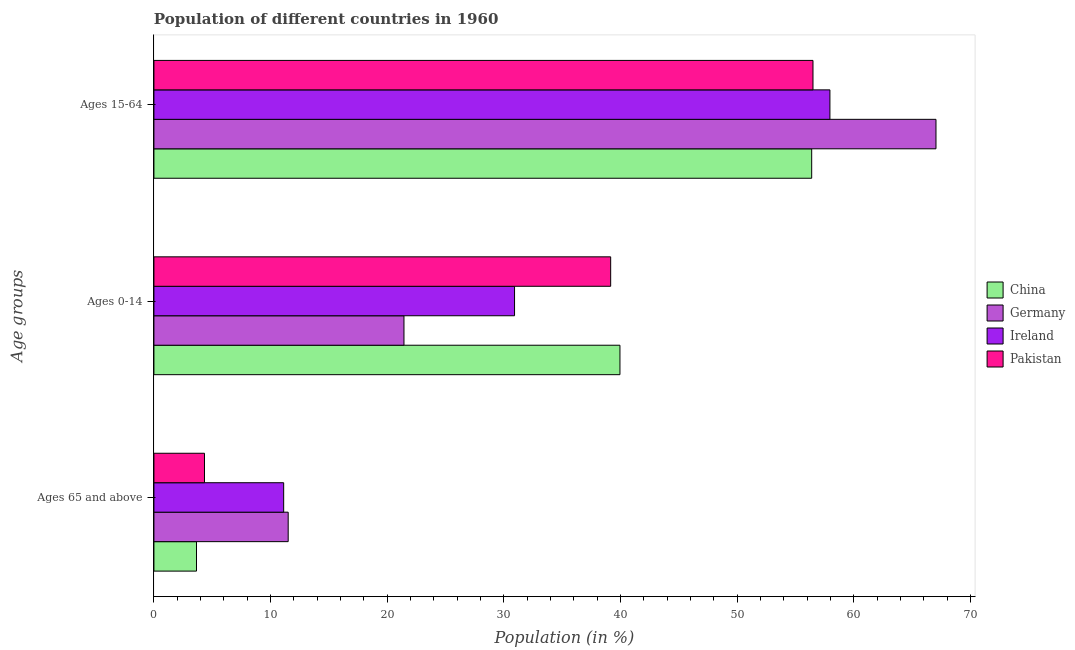How many different coloured bars are there?
Provide a succinct answer. 4. Are the number of bars per tick equal to the number of legend labels?
Ensure brevity in your answer.  Yes. What is the label of the 2nd group of bars from the top?
Ensure brevity in your answer.  Ages 0-14. What is the percentage of population within the age-group of 65 and above in Pakistan?
Provide a short and direct response. 4.33. Across all countries, what is the maximum percentage of population within the age-group 15-64?
Make the answer very short. 67.05. Across all countries, what is the minimum percentage of population within the age-group 0-14?
Offer a terse response. 21.44. In which country was the percentage of population within the age-group 0-14 maximum?
Your answer should be compact. China. In which country was the percentage of population within the age-group of 65 and above minimum?
Ensure brevity in your answer.  China. What is the total percentage of population within the age-group 0-14 in the graph?
Provide a short and direct response. 131.47. What is the difference between the percentage of population within the age-group 0-14 in Pakistan and that in China?
Give a very brief answer. -0.8. What is the difference between the percentage of population within the age-group of 65 and above in Ireland and the percentage of population within the age-group 0-14 in Pakistan?
Your answer should be very brief. -28.04. What is the average percentage of population within the age-group 15-64 per country?
Provide a short and direct response. 59.48. What is the difference between the percentage of population within the age-group 0-14 and percentage of population within the age-group of 65 and above in Germany?
Ensure brevity in your answer.  9.93. What is the ratio of the percentage of population within the age-group of 65 and above in Pakistan to that in China?
Give a very brief answer. 1.19. What is the difference between the highest and the second highest percentage of population within the age-group 0-14?
Ensure brevity in your answer.  0.8. What is the difference between the highest and the lowest percentage of population within the age-group 0-14?
Provide a succinct answer. 18.52. What does the 4th bar from the top in Ages 65 and above represents?
Your answer should be compact. China. What does the 4th bar from the bottom in Ages 65 and above represents?
Your response must be concise. Pakistan. Are all the bars in the graph horizontal?
Your response must be concise. Yes. How many countries are there in the graph?
Ensure brevity in your answer.  4. What is the difference between two consecutive major ticks on the X-axis?
Ensure brevity in your answer.  10. Are the values on the major ticks of X-axis written in scientific E-notation?
Provide a succinct answer. No. Does the graph contain any zero values?
Your answer should be very brief. No. Where does the legend appear in the graph?
Give a very brief answer. Center right. How are the legend labels stacked?
Provide a succinct answer. Vertical. What is the title of the graph?
Offer a very short reply. Population of different countries in 1960. Does "Chile" appear as one of the legend labels in the graph?
Give a very brief answer. No. What is the label or title of the X-axis?
Offer a terse response. Population (in %). What is the label or title of the Y-axis?
Keep it short and to the point. Age groups. What is the Population (in %) of China in Ages 65 and above?
Provide a succinct answer. 3.65. What is the Population (in %) of Germany in Ages 65 and above?
Offer a very short reply. 11.51. What is the Population (in %) of Ireland in Ages 65 and above?
Give a very brief answer. 11.12. What is the Population (in %) of Pakistan in Ages 65 and above?
Keep it short and to the point. 4.33. What is the Population (in %) in China in Ages 0-14?
Offer a very short reply. 39.96. What is the Population (in %) in Germany in Ages 0-14?
Offer a very short reply. 21.44. What is the Population (in %) in Ireland in Ages 0-14?
Your response must be concise. 30.92. What is the Population (in %) of Pakistan in Ages 0-14?
Your answer should be very brief. 39.16. What is the Population (in %) in China in Ages 15-64?
Your response must be concise. 56.39. What is the Population (in %) of Germany in Ages 15-64?
Give a very brief answer. 67.05. What is the Population (in %) of Ireland in Ages 15-64?
Your response must be concise. 57.96. What is the Population (in %) of Pakistan in Ages 15-64?
Your answer should be compact. 56.51. Across all Age groups, what is the maximum Population (in %) of China?
Ensure brevity in your answer.  56.39. Across all Age groups, what is the maximum Population (in %) of Germany?
Your answer should be very brief. 67.05. Across all Age groups, what is the maximum Population (in %) of Ireland?
Your answer should be compact. 57.96. Across all Age groups, what is the maximum Population (in %) in Pakistan?
Your answer should be very brief. 56.51. Across all Age groups, what is the minimum Population (in %) of China?
Provide a short and direct response. 3.65. Across all Age groups, what is the minimum Population (in %) of Germany?
Your answer should be very brief. 11.51. Across all Age groups, what is the minimum Population (in %) of Ireland?
Offer a very short reply. 11.12. Across all Age groups, what is the minimum Population (in %) of Pakistan?
Offer a terse response. 4.33. What is the total Population (in %) in China in the graph?
Keep it short and to the point. 100. What is the total Population (in %) in Pakistan in the graph?
Offer a very short reply. 100. What is the difference between the Population (in %) in China in Ages 65 and above and that in Ages 0-14?
Your response must be concise. -36.31. What is the difference between the Population (in %) of Germany in Ages 65 and above and that in Ages 0-14?
Provide a short and direct response. -9.93. What is the difference between the Population (in %) in Ireland in Ages 65 and above and that in Ages 0-14?
Your response must be concise. -19.79. What is the difference between the Population (in %) of Pakistan in Ages 65 and above and that in Ages 0-14?
Offer a terse response. -34.83. What is the difference between the Population (in %) of China in Ages 65 and above and that in Ages 15-64?
Ensure brevity in your answer.  -52.74. What is the difference between the Population (in %) in Germany in Ages 65 and above and that in Ages 15-64?
Keep it short and to the point. -55.54. What is the difference between the Population (in %) of Ireland in Ages 65 and above and that in Ages 15-64?
Your response must be concise. -46.83. What is the difference between the Population (in %) in Pakistan in Ages 65 and above and that in Ages 15-64?
Offer a very short reply. -52.17. What is the difference between the Population (in %) in China in Ages 0-14 and that in Ages 15-64?
Your answer should be compact. -16.44. What is the difference between the Population (in %) in Germany in Ages 0-14 and that in Ages 15-64?
Offer a terse response. -45.61. What is the difference between the Population (in %) of Ireland in Ages 0-14 and that in Ages 15-64?
Your response must be concise. -27.04. What is the difference between the Population (in %) in Pakistan in Ages 0-14 and that in Ages 15-64?
Your answer should be very brief. -17.35. What is the difference between the Population (in %) in China in Ages 65 and above and the Population (in %) in Germany in Ages 0-14?
Offer a very short reply. -17.79. What is the difference between the Population (in %) of China in Ages 65 and above and the Population (in %) of Ireland in Ages 0-14?
Your answer should be compact. -27.27. What is the difference between the Population (in %) of China in Ages 65 and above and the Population (in %) of Pakistan in Ages 0-14?
Offer a terse response. -35.51. What is the difference between the Population (in %) of Germany in Ages 65 and above and the Population (in %) of Ireland in Ages 0-14?
Your answer should be very brief. -19.41. What is the difference between the Population (in %) of Germany in Ages 65 and above and the Population (in %) of Pakistan in Ages 0-14?
Your response must be concise. -27.65. What is the difference between the Population (in %) in Ireland in Ages 65 and above and the Population (in %) in Pakistan in Ages 0-14?
Provide a succinct answer. -28.04. What is the difference between the Population (in %) in China in Ages 65 and above and the Population (in %) in Germany in Ages 15-64?
Provide a succinct answer. -63.4. What is the difference between the Population (in %) of China in Ages 65 and above and the Population (in %) of Ireland in Ages 15-64?
Your answer should be very brief. -54.31. What is the difference between the Population (in %) in China in Ages 65 and above and the Population (in %) in Pakistan in Ages 15-64?
Make the answer very short. -52.86. What is the difference between the Population (in %) of Germany in Ages 65 and above and the Population (in %) of Ireland in Ages 15-64?
Offer a very short reply. -46.45. What is the difference between the Population (in %) in Germany in Ages 65 and above and the Population (in %) in Pakistan in Ages 15-64?
Offer a very short reply. -44.99. What is the difference between the Population (in %) of Ireland in Ages 65 and above and the Population (in %) of Pakistan in Ages 15-64?
Provide a short and direct response. -45.38. What is the difference between the Population (in %) of China in Ages 0-14 and the Population (in %) of Germany in Ages 15-64?
Your answer should be very brief. -27.1. What is the difference between the Population (in %) of China in Ages 0-14 and the Population (in %) of Ireland in Ages 15-64?
Ensure brevity in your answer.  -18. What is the difference between the Population (in %) of China in Ages 0-14 and the Population (in %) of Pakistan in Ages 15-64?
Keep it short and to the point. -16.55. What is the difference between the Population (in %) of Germany in Ages 0-14 and the Population (in %) of Ireland in Ages 15-64?
Offer a terse response. -36.52. What is the difference between the Population (in %) of Germany in Ages 0-14 and the Population (in %) of Pakistan in Ages 15-64?
Ensure brevity in your answer.  -35.07. What is the difference between the Population (in %) of Ireland in Ages 0-14 and the Population (in %) of Pakistan in Ages 15-64?
Make the answer very short. -25.59. What is the average Population (in %) of China per Age groups?
Provide a succinct answer. 33.33. What is the average Population (in %) of Germany per Age groups?
Make the answer very short. 33.33. What is the average Population (in %) of Ireland per Age groups?
Make the answer very short. 33.33. What is the average Population (in %) in Pakistan per Age groups?
Provide a succinct answer. 33.33. What is the difference between the Population (in %) in China and Population (in %) in Germany in Ages 65 and above?
Your answer should be compact. -7.86. What is the difference between the Population (in %) of China and Population (in %) of Ireland in Ages 65 and above?
Your answer should be very brief. -7.47. What is the difference between the Population (in %) in China and Population (in %) in Pakistan in Ages 65 and above?
Ensure brevity in your answer.  -0.68. What is the difference between the Population (in %) of Germany and Population (in %) of Ireland in Ages 65 and above?
Make the answer very short. 0.39. What is the difference between the Population (in %) of Germany and Population (in %) of Pakistan in Ages 65 and above?
Keep it short and to the point. 7.18. What is the difference between the Population (in %) in Ireland and Population (in %) in Pakistan in Ages 65 and above?
Your response must be concise. 6.79. What is the difference between the Population (in %) in China and Population (in %) in Germany in Ages 0-14?
Offer a very short reply. 18.52. What is the difference between the Population (in %) of China and Population (in %) of Ireland in Ages 0-14?
Your answer should be very brief. 9.04. What is the difference between the Population (in %) in China and Population (in %) in Pakistan in Ages 0-14?
Ensure brevity in your answer.  0.8. What is the difference between the Population (in %) of Germany and Population (in %) of Ireland in Ages 0-14?
Provide a succinct answer. -9.48. What is the difference between the Population (in %) of Germany and Population (in %) of Pakistan in Ages 0-14?
Provide a short and direct response. -17.72. What is the difference between the Population (in %) in Ireland and Population (in %) in Pakistan in Ages 0-14?
Give a very brief answer. -8.24. What is the difference between the Population (in %) of China and Population (in %) of Germany in Ages 15-64?
Your response must be concise. -10.66. What is the difference between the Population (in %) of China and Population (in %) of Ireland in Ages 15-64?
Offer a very short reply. -1.56. What is the difference between the Population (in %) of China and Population (in %) of Pakistan in Ages 15-64?
Your answer should be compact. -0.11. What is the difference between the Population (in %) in Germany and Population (in %) in Ireland in Ages 15-64?
Provide a short and direct response. 9.09. What is the difference between the Population (in %) in Germany and Population (in %) in Pakistan in Ages 15-64?
Offer a terse response. 10.54. What is the difference between the Population (in %) of Ireland and Population (in %) of Pakistan in Ages 15-64?
Keep it short and to the point. 1.45. What is the ratio of the Population (in %) of China in Ages 65 and above to that in Ages 0-14?
Provide a succinct answer. 0.09. What is the ratio of the Population (in %) of Germany in Ages 65 and above to that in Ages 0-14?
Keep it short and to the point. 0.54. What is the ratio of the Population (in %) in Ireland in Ages 65 and above to that in Ages 0-14?
Ensure brevity in your answer.  0.36. What is the ratio of the Population (in %) of Pakistan in Ages 65 and above to that in Ages 0-14?
Your answer should be very brief. 0.11. What is the ratio of the Population (in %) of China in Ages 65 and above to that in Ages 15-64?
Your answer should be compact. 0.06. What is the ratio of the Population (in %) in Germany in Ages 65 and above to that in Ages 15-64?
Provide a succinct answer. 0.17. What is the ratio of the Population (in %) of Ireland in Ages 65 and above to that in Ages 15-64?
Your answer should be compact. 0.19. What is the ratio of the Population (in %) of Pakistan in Ages 65 and above to that in Ages 15-64?
Offer a terse response. 0.08. What is the ratio of the Population (in %) in China in Ages 0-14 to that in Ages 15-64?
Give a very brief answer. 0.71. What is the ratio of the Population (in %) of Germany in Ages 0-14 to that in Ages 15-64?
Provide a succinct answer. 0.32. What is the ratio of the Population (in %) in Ireland in Ages 0-14 to that in Ages 15-64?
Your response must be concise. 0.53. What is the ratio of the Population (in %) of Pakistan in Ages 0-14 to that in Ages 15-64?
Provide a short and direct response. 0.69. What is the difference between the highest and the second highest Population (in %) of China?
Provide a succinct answer. 16.44. What is the difference between the highest and the second highest Population (in %) of Germany?
Provide a short and direct response. 45.61. What is the difference between the highest and the second highest Population (in %) of Ireland?
Your answer should be very brief. 27.04. What is the difference between the highest and the second highest Population (in %) in Pakistan?
Keep it short and to the point. 17.35. What is the difference between the highest and the lowest Population (in %) in China?
Provide a short and direct response. 52.74. What is the difference between the highest and the lowest Population (in %) in Germany?
Offer a very short reply. 55.54. What is the difference between the highest and the lowest Population (in %) of Ireland?
Offer a very short reply. 46.83. What is the difference between the highest and the lowest Population (in %) of Pakistan?
Make the answer very short. 52.17. 